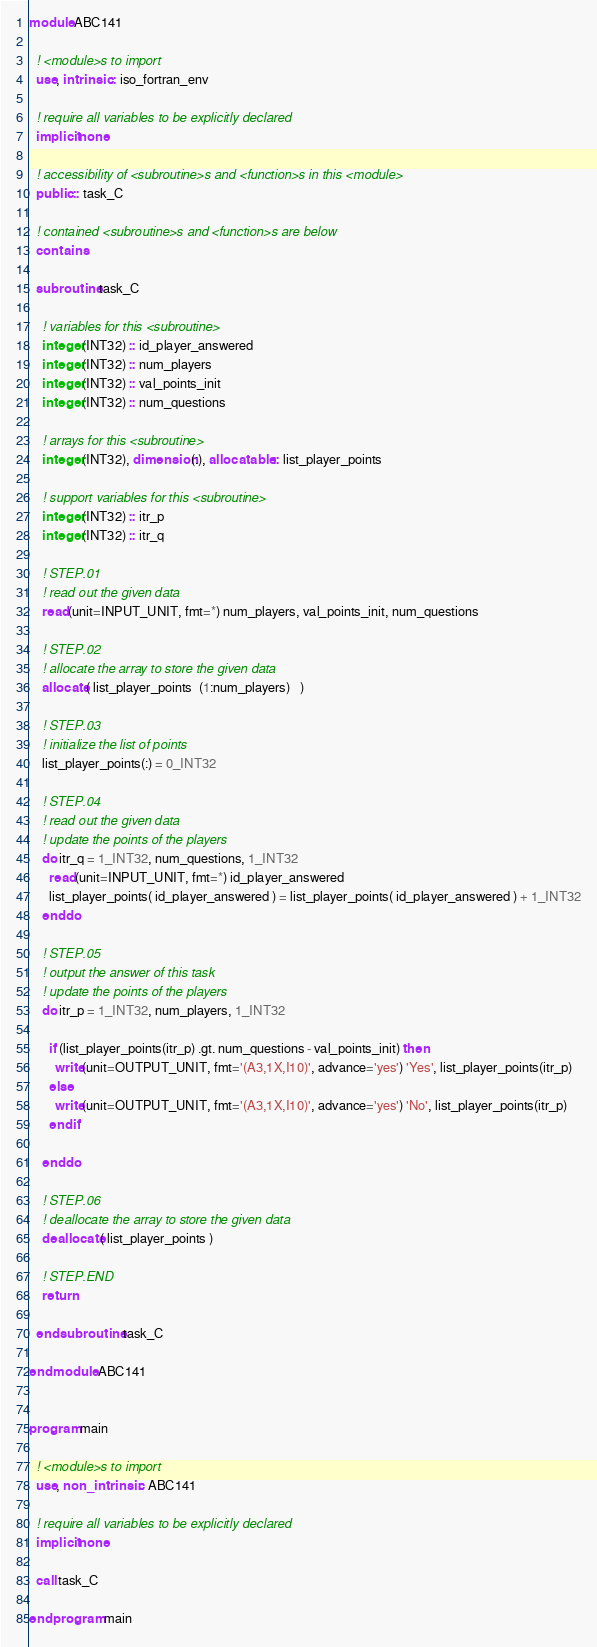<code> <loc_0><loc_0><loc_500><loc_500><_FORTRAN_>module ABC141

  ! <module>s to import
  use, intrinsic :: iso_fortran_env

  ! require all variables to be explicitly declared
  implicit none

  ! accessibility of <subroutine>s and <function>s in this <module>
  public :: task_C

  ! contained <subroutine>s and <function>s are below
  contains

  subroutine task_C

    ! variables for this <subroutine>
    integer(INT32) :: id_player_answered
    integer(INT32) :: num_players
    integer(INT32) :: val_points_init
    integer(INT32) :: num_questions

    ! arrays for this <subroutine>
    integer(INT32), dimension(:), allocatable :: list_player_points

    ! support variables for this <subroutine>
    integer(INT32) :: itr_p
    integer(INT32) :: itr_q

    ! STEP.01
    ! read out the given data
    read(unit=INPUT_UNIT, fmt=*) num_players, val_points_init, num_questions

    ! STEP.02
    ! allocate the array to store the given data
    allocate( list_player_points  (1:num_players)   )

    ! STEP.03
    ! initialize the list of points
    list_player_points(:) = 0_INT32

    ! STEP.04
    ! read out the given data
    ! update the points of the players
    do itr_q = 1_INT32, num_questions, 1_INT32
      read(unit=INPUT_UNIT, fmt=*) id_player_answered
      list_player_points( id_player_answered ) = list_player_points( id_player_answered ) + 1_INT32
    end do

    ! STEP.05
    ! output the answer of this task
    ! update the points of the players
    do itr_p = 1_INT32, num_players, 1_INT32

      if (list_player_points(itr_p) .gt. num_questions - val_points_init) then
        write(unit=OUTPUT_UNIT, fmt='(A3,1X,I10)', advance='yes') 'Yes', list_player_points(itr_p)
      else
        write(unit=OUTPUT_UNIT, fmt='(A3,1X,I10)', advance='yes') 'No', list_player_points(itr_p)
      end if

    end do

    ! STEP.06
    ! deallocate the array to store the given data
    deallocate( list_player_points )

    ! STEP.END
    return

  end subroutine task_C

end module ABC141


program main

  ! <module>s to import
  use, non_intrinsic :: ABC141

  ! require all variables to be explicitly declared
  implicit none

  call task_C

end program main</code> 